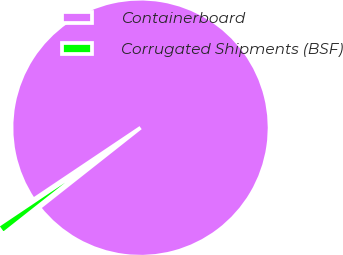Convert chart. <chart><loc_0><loc_0><loc_500><loc_500><pie_chart><fcel>Containerboard<fcel>Corrugated Shipments (BSF)<nl><fcel>98.77%<fcel>1.23%<nl></chart> 